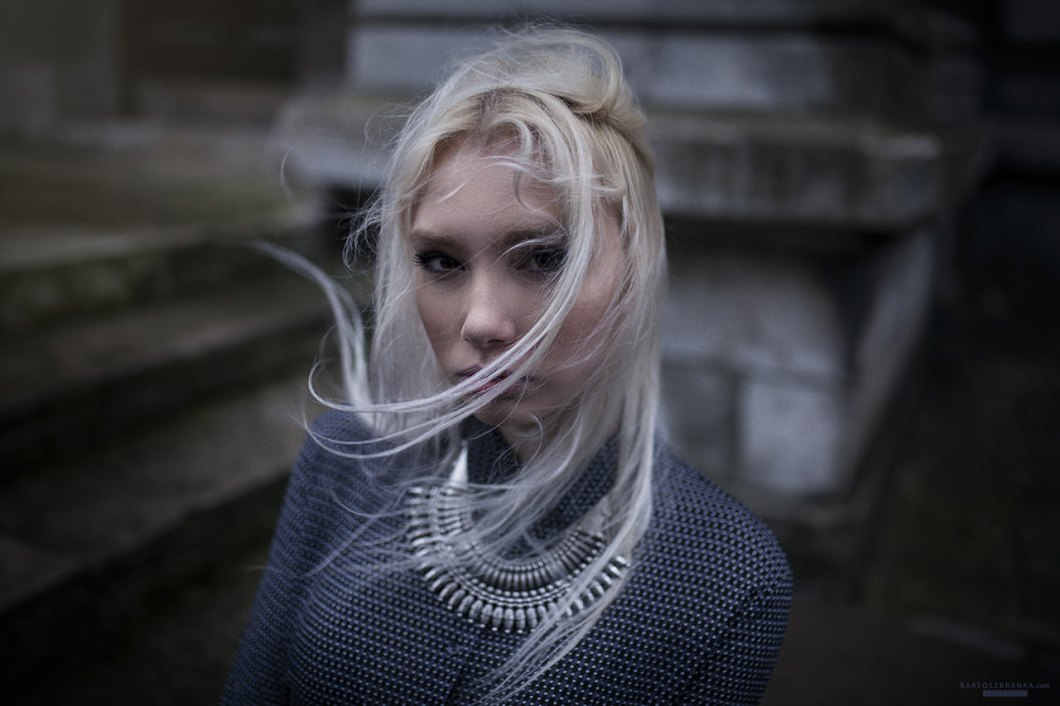Imagine a story behind this scene where the woman is waiting for someone. Describe the ambiance and what she might be thinking. The scene is set on an overcast afternoon, with a gentle but persistent wind swaying her long, platinum hair. The woman stands at the foot of an old, weathered staircase, the cold stone echoing memories of a bygone era. She clutches her sweater closer, seeking warmth not just from the chill but from the anticipation of a long-awaited meeting. Her eyes, though resolute, betray a flicker of uncertainty and hope. She might be pondering the words they exchanged, replaying moments from their last encounter, and the promises made under an equally grey sky. The air is thick with the scent of rain and the unspoken words that hover in the atmosphere. 